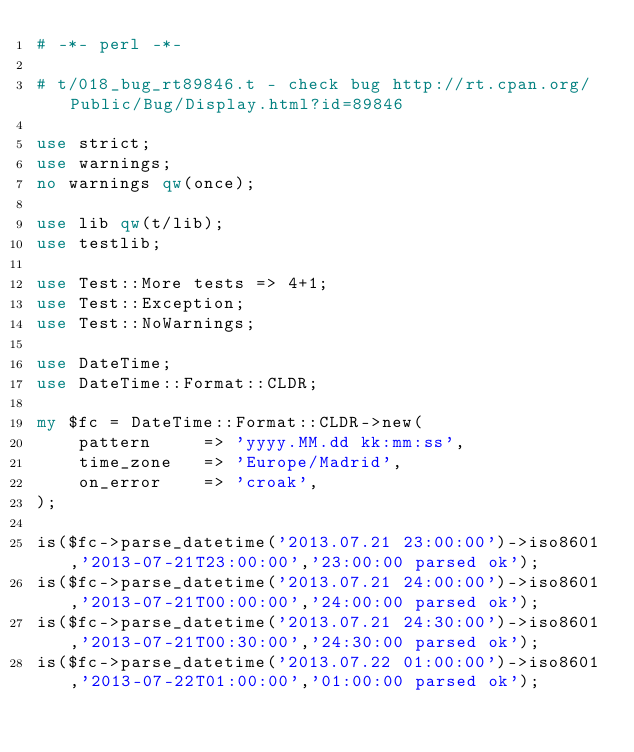Convert code to text. <code><loc_0><loc_0><loc_500><loc_500><_Perl_># -*- perl -*-

# t/018_bug_rt89846.t - check bug http://rt.cpan.org/Public/Bug/Display.html?id=89846

use strict;
use warnings;
no warnings qw(once);

use lib qw(t/lib);
use testlib;

use Test::More tests => 4+1;
use Test::Exception;
use Test::NoWarnings;

use DateTime;
use DateTime::Format::CLDR;

my $fc = DateTime::Format::CLDR->new(
    pattern     => 'yyyy.MM.dd kk:mm:ss',
    time_zone   => 'Europe/Madrid',
    on_error    => 'croak',
);

is($fc->parse_datetime('2013.07.21 23:00:00')->iso8601,'2013-07-21T23:00:00','23:00:00 parsed ok');
is($fc->parse_datetime('2013.07.21 24:00:00')->iso8601,'2013-07-21T00:00:00','24:00:00 parsed ok');
is($fc->parse_datetime('2013.07.21 24:30:00')->iso8601,'2013-07-21T00:30:00','24:30:00 parsed ok');
is($fc->parse_datetime('2013.07.22 01:00:00')->iso8601,'2013-07-22T01:00:00','01:00:00 parsed ok');</code> 